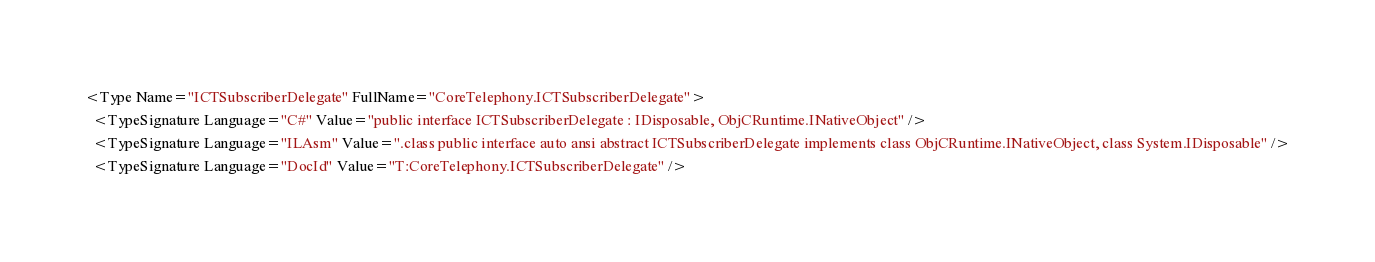<code> <loc_0><loc_0><loc_500><loc_500><_XML_><Type Name="ICTSubscriberDelegate" FullName="CoreTelephony.ICTSubscriberDelegate">
  <TypeSignature Language="C#" Value="public interface ICTSubscriberDelegate : IDisposable, ObjCRuntime.INativeObject" />
  <TypeSignature Language="ILAsm" Value=".class public interface auto ansi abstract ICTSubscriberDelegate implements class ObjCRuntime.INativeObject, class System.IDisposable" />
  <TypeSignature Language="DocId" Value="T:CoreTelephony.ICTSubscriberDelegate" /></code> 